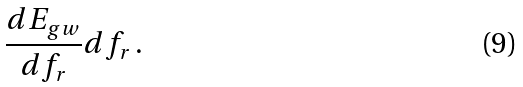<formula> <loc_0><loc_0><loc_500><loc_500>\frac { d E _ { g w } } { d f _ { r } } d f _ { r } \, .</formula> 